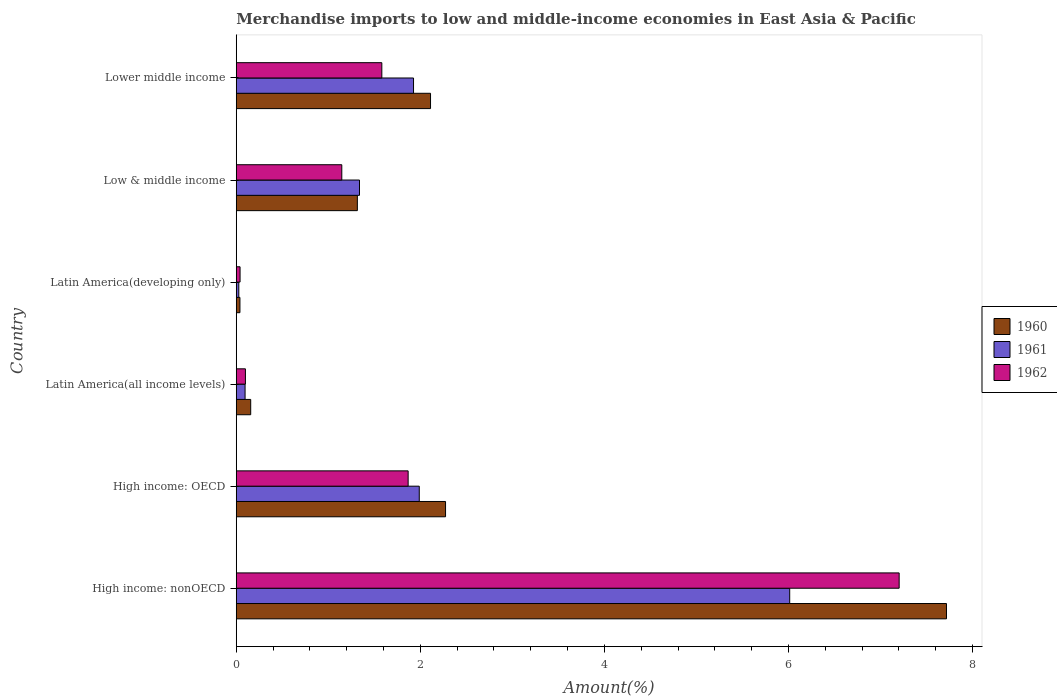How many different coloured bars are there?
Keep it short and to the point. 3. How many groups of bars are there?
Offer a terse response. 6. Are the number of bars per tick equal to the number of legend labels?
Ensure brevity in your answer.  Yes. Are the number of bars on each tick of the Y-axis equal?
Give a very brief answer. Yes. What is the label of the 3rd group of bars from the top?
Offer a terse response. Latin America(developing only). What is the percentage of amount earned from merchandise imports in 1961 in Latin America(developing only)?
Ensure brevity in your answer.  0.03. Across all countries, what is the maximum percentage of amount earned from merchandise imports in 1962?
Offer a very short reply. 7.2. Across all countries, what is the minimum percentage of amount earned from merchandise imports in 1962?
Your response must be concise. 0.04. In which country was the percentage of amount earned from merchandise imports in 1961 maximum?
Give a very brief answer. High income: nonOECD. In which country was the percentage of amount earned from merchandise imports in 1960 minimum?
Provide a short and direct response. Latin America(developing only). What is the total percentage of amount earned from merchandise imports in 1961 in the graph?
Offer a terse response. 11.39. What is the difference between the percentage of amount earned from merchandise imports in 1962 in High income: OECD and that in High income: nonOECD?
Your response must be concise. -5.33. What is the difference between the percentage of amount earned from merchandise imports in 1962 in High income: OECD and the percentage of amount earned from merchandise imports in 1961 in High income: nonOECD?
Your response must be concise. -4.15. What is the average percentage of amount earned from merchandise imports in 1960 per country?
Give a very brief answer. 2.27. What is the difference between the percentage of amount earned from merchandise imports in 1962 and percentage of amount earned from merchandise imports in 1960 in Latin America(all income levels)?
Provide a succinct answer. -0.06. What is the ratio of the percentage of amount earned from merchandise imports in 1962 in High income: OECD to that in Latin America(developing only)?
Keep it short and to the point. 45.19. Is the percentage of amount earned from merchandise imports in 1961 in High income: OECD less than that in Latin America(all income levels)?
Provide a succinct answer. No. What is the difference between the highest and the second highest percentage of amount earned from merchandise imports in 1961?
Ensure brevity in your answer.  4.02. What is the difference between the highest and the lowest percentage of amount earned from merchandise imports in 1960?
Give a very brief answer. 7.68. How many bars are there?
Offer a terse response. 18. Are all the bars in the graph horizontal?
Ensure brevity in your answer.  Yes. How many countries are there in the graph?
Your response must be concise. 6. What is the difference between two consecutive major ticks on the X-axis?
Make the answer very short. 2. Are the values on the major ticks of X-axis written in scientific E-notation?
Provide a succinct answer. No. Does the graph contain grids?
Keep it short and to the point. No. How many legend labels are there?
Give a very brief answer. 3. What is the title of the graph?
Offer a very short reply. Merchandise imports to low and middle-income economies in East Asia & Pacific. Does "1984" appear as one of the legend labels in the graph?
Make the answer very short. No. What is the label or title of the X-axis?
Your answer should be compact. Amount(%). What is the label or title of the Y-axis?
Your answer should be compact. Country. What is the Amount(%) in 1960 in High income: nonOECD?
Your response must be concise. 7.72. What is the Amount(%) of 1961 in High income: nonOECD?
Provide a short and direct response. 6.01. What is the Amount(%) in 1962 in High income: nonOECD?
Ensure brevity in your answer.  7.2. What is the Amount(%) in 1960 in High income: OECD?
Your response must be concise. 2.27. What is the Amount(%) of 1961 in High income: OECD?
Offer a very short reply. 1.99. What is the Amount(%) in 1962 in High income: OECD?
Keep it short and to the point. 1.87. What is the Amount(%) of 1960 in Latin America(all income levels)?
Give a very brief answer. 0.16. What is the Amount(%) of 1961 in Latin America(all income levels)?
Your answer should be very brief. 0.1. What is the Amount(%) of 1962 in Latin America(all income levels)?
Your answer should be compact. 0.1. What is the Amount(%) of 1960 in Latin America(developing only)?
Provide a succinct answer. 0.04. What is the Amount(%) of 1961 in Latin America(developing only)?
Keep it short and to the point. 0.03. What is the Amount(%) of 1962 in Latin America(developing only)?
Offer a very short reply. 0.04. What is the Amount(%) of 1960 in Low & middle income?
Give a very brief answer. 1.32. What is the Amount(%) in 1961 in Low & middle income?
Your answer should be compact. 1.34. What is the Amount(%) of 1962 in Low & middle income?
Your answer should be very brief. 1.15. What is the Amount(%) of 1960 in Lower middle income?
Keep it short and to the point. 2.11. What is the Amount(%) in 1961 in Lower middle income?
Keep it short and to the point. 1.93. What is the Amount(%) in 1962 in Lower middle income?
Offer a very short reply. 1.58. Across all countries, what is the maximum Amount(%) in 1960?
Make the answer very short. 7.72. Across all countries, what is the maximum Amount(%) of 1961?
Your answer should be very brief. 6.01. Across all countries, what is the maximum Amount(%) in 1962?
Your response must be concise. 7.2. Across all countries, what is the minimum Amount(%) of 1960?
Your answer should be compact. 0.04. Across all countries, what is the minimum Amount(%) in 1961?
Keep it short and to the point. 0.03. Across all countries, what is the minimum Amount(%) of 1962?
Provide a short and direct response. 0.04. What is the total Amount(%) of 1960 in the graph?
Make the answer very short. 13.61. What is the total Amount(%) in 1961 in the graph?
Your answer should be compact. 11.39. What is the total Amount(%) in 1962 in the graph?
Provide a short and direct response. 11.94. What is the difference between the Amount(%) in 1960 in High income: nonOECD and that in High income: OECD?
Your answer should be very brief. 5.44. What is the difference between the Amount(%) in 1961 in High income: nonOECD and that in High income: OECD?
Your answer should be very brief. 4.02. What is the difference between the Amount(%) of 1962 in High income: nonOECD and that in High income: OECD?
Offer a very short reply. 5.33. What is the difference between the Amount(%) of 1960 in High income: nonOECD and that in Latin America(all income levels)?
Your answer should be compact. 7.56. What is the difference between the Amount(%) in 1961 in High income: nonOECD and that in Latin America(all income levels)?
Ensure brevity in your answer.  5.92. What is the difference between the Amount(%) in 1962 in High income: nonOECD and that in Latin America(all income levels)?
Give a very brief answer. 7.1. What is the difference between the Amount(%) in 1960 in High income: nonOECD and that in Latin America(developing only)?
Provide a succinct answer. 7.68. What is the difference between the Amount(%) in 1961 in High income: nonOECD and that in Latin America(developing only)?
Make the answer very short. 5.99. What is the difference between the Amount(%) in 1962 in High income: nonOECD and that in Latin America(developing only)?
Give a very brief answer. 7.16. What is the difference between the Amount(%) in 1960 in High income: nonOECD and that in Low & middle income?
Provide a succinct answer. 6.4. What is the difference between the Amount(%) of 1961 in High income: nonOECD and that in Low & middle income?
Make the answer very short. 4.67. What is the difference between the Amount(%) of 1962 in High income: nonOECD and that in Low & middle income?
Your answer should be compact. 6.06. What is the difference between the Amount(%) of 1960 in High income: nonOECD and that in Lower middle income?
Make the answer very short. 5.61. What is the difference between the Amount(%) in 1961 in High income: nonOECD and that in Lower middle income?
Offer a very short reply. 4.09. What is the difference between the Amount(%) in 1962 in High income: nonOECD and that in Lower middle income?
Offer a terse response. 5.62. What is the difference between the Amount(%) in 1960 in High income: OECD and that in Latin America(all income levels)?
Your answer should be very brief. 2.12. What is the difference between the Amount(%) of 1961 in High income: OECD and that in Latin America(all income levels)?
Offer a very short reply. 1.89. What is the difference between the Amount(%) of 1962 in High income: OECD and that in Latin America(all income levels)?
Ensure brevity in your answer.  1.77. What is the difference between the Amount(%) of 1960 in High income: OECD and that in Latin America(developing only)?
Ensure brevity in your answer.  2.23. What is the difference between the Amount(%) in 1961 in High income: OECD and that in Latin America(developing only)?
Your answer should be compact. 1.96. What is the difference between the Amount(%) in 1962 in High income: OECD and that in Latin America(developing only)?
Make the answer very short. 1.83. What is the difference between the Amount(%) in 1960 in High income: OECD and that in Low & middle income?
Provide a short and direct response. 0.96. What is the difference between the Amount(%) in 1961 in High income: OECD and that in Low & middle income?
Give a very brief answer. 0.65. What is the difference between the Amount(%) in 1962 in High income: OECD and that in Low & middle income?
Offer a very short reply. 0.72. What is the difference between the Amount(%) in 1960 in High income: OECD and that in Lower middle income?
Make the answer very short. 0.16. What is the difference between the Amount(%) in 1961 in High income: OECD and that in Lower middle income?
Your response must be concise. 0.06. What is the difference between the Amount(%) in 1962 in High income: OECD and that in Lower middle income?
Your response must be concise. 0.29. What is the difference between the Amount(%) of 1960 in Latin America(all income levels) and that in Latin America(developing only)?
Make the answer very short. 0.12. What is the difference between the Amount(%) of 1961 in Latin America(all income levels) and that in Latin America(developing only)?
Provide a short and direct response. 0.07. What is the difference between the Amount(%) of 1962 in Latin America(all income levels) and that in Latin America(developing only)?
Keep it short and to the point. 0.06. What is the difference between the Amount(%) in 1960 in Latin America(all income levels) and that in Low & middle income?
Make the answer very short. -1.16. What is the difference between the Amount(%) of 1961 in Latin America(all income levels) and that in Low & middle income?
Provide a succinct answer. -1.24. What is the difference between the Amount(%) in 1962 in Latin America(all income levels) and that in Low & middle income?
Provide a succinct answer. -1.05. What is the difference between the Amount(%) in 1960 in Latin America(all income levels) and that in Lower middle income?
Keep it short and to the point. -1.95. What is the difference between the Amount(%) in 1961 in Latin America(all income levels) and that in Lower middle income?
Provide a succinct answer. -1.83. What is the difference between the Amount(%) of 1962 in Latin America(all income levels) and that in Lower middle income?
Make the answer very short. -1.48. What is the difference between the Amount(%) in 1960 in Latin America(developing only) and that in Low & middle income?
Make the answer very short. -1.28. What is the difference between the Amount(%) of 1961 in Latin America(developing only) and that in Low & middle income?
Give a very brief answer. -1.31. What is the difference between the Amount(%) of 1962 in Latin America(developing only) and that in Low & middle income?
Make the answer very short. -1.11. What is the difference between the Amount(%) of 1960 in Latin America(developing only) and that in Lower middle income?
Offer a terse response. -2.07. What is the difference between the Amount(%) in 1961 in Latin America(developing only) and that in Lower middle income?
Your answer should be very brief. -1.9. What is the difference between the Amount(%) in 1962 in Latin America(developing only) and that in Lower middle income?
Keep it short and to the point. -1.54. What is the difference between the Amount(%) in 1960 in Low & middle income and that in Lower middle income?
Your response must be concise. -0.8. What is the difference between the Amount(%) in 1961 in Low & middle income and that in Lower middle income?
Your answer should be very brief. -0.59. What is the difference between the Amount(%) of 1962 in Low & middle income and that in Lower middle income?
Give a very brief answer. -0.43. What is the difference between the Amount(%) of 1960 in High income: nonOECD and the Amount(%) of 1961 in High income: OECD?
Give a very brief answer. 5.73. What is the difference between the Amount(%) in 1960 in High income: nonOECD and the Amount(%) in 1962 in High income: OECD?
Ensure brevity in your answer.  5.85. What is the difference between the Amount(%) of 1961 in High income: nonOECD and the Amount(%) of 1962 in High income: OECD?
Provide a succinct answer. 4.15. What is the difference between the Amount(%) in 1960 in High income: nonOECD and the Amount(%) in 1961 in Latin America(all income levels)?
Offer a very short reply. 7.62. What is the difference between the Amount(%) of 1960 in High income: nonOECD and the Amount(%) of 1962 in Latin America(all income levels)?
Give a very brief answer. 7.62. What is the difference between the Amount(%) of 1961 in High income: nonOECD and the Amount(%) of 1962 in Latin America(all income levels)?
Your answer should be very brief. 5.91. What is the difference between the Amount(%) of 1960 in High income: nonOECD and the Amount(%) of 1961 in Latin America(developing only)?
Ensure brevity in your answer.  7.69. What is the difference between the Amount(%) in 1960 in High income: nonOECD and the Amount(%) in 1962 in Latin America(developing only)?
Your answer should be very brief. 7.67. What is the difference between the Amount(%) of 1961 in High income: nonOECD and the Amount(%) of 1962 in Latin America(developing only)?
Give a very brief answer. 5.97. What is the difference between the Amount(%) of 1960 in High income: nonOECD and the Amount(%) of 1961 in Low & middle income?
Your answer should be very brief. 6.38. What is the difference between the Amount(%) of 1960 in High income: nonOECD and the Amount(%) of 1962 in Low & middle income?
Your answer should be very brief. 6.57. What is the difference between the Amount(%) of 1961 in High income: nonOECD and the Amount(%) of 1962 in Low & middle income?
Provide a succinct answer. 4.87. What is the difference between the Amount(%) of 1960 in High income: nonOECD and the Amount(%) of 1961 in Lower middle income?
Offer a terse response. 5.79. What is the difference between the Amount(%) of 1960 in High income: nonOECD and the Amount(%) of 1962 in Lower middle income?
Provide a succinct answer. 6.13. What is the difference between the Amount(%) of 1961 in High income: nonOECD and the Amount(%) of 1962 in Lower middle income?
Keep it short and to the point. 4.43. What is the difference between the Amount(%) in 1960 in High income: OECD and the Amount(%) in 1961 in Latin America(all income levels)?
Your response must be concise. 2.18. What is the difference between the Amount(%) in 1960 in High income: OECD and the Amount(%) in 1962 in Latin America(all income levels)?
Keep it short and to the point. 2.17. What is the difference between the Amount(%) in 1961 in High income: OECD and the Amount(%) in 1962 in Latin America(all income levels)?
Offer a very short reply. 1.89. What is the difference between the Amount(%) in 1960 in High income: OECD and the Amount(%) in 1961 in Latin America(developing only)?
Keep it short and to the point. 2.25. What is the difference between the Amount(%) in 1960 in High income: OECD and the Amount(%) in 1962 in Latin America(developing only)?
Your answer should be compact. 2.23. What is the difference between the Amount(%) of 1961 in High income: OECD and the Amount(%) of 1962 in Latin America(developing only)?
Make the answer very short. 1.95. What is the difference between the Amount(%) of 1960 in High income: OECD and the Amount(%) of 1961 in Low & middle income?
Your response must be concise. 0.93. What is the difference between the Amount(%) in 1960 in High income: OECD and the Amount(%) in 1962 in Low & middle income?
Your answer should be compact. 1.13. What is the difference between the Amount(%) of 1961 in High income: OECD and the Amount(%) of 1962 in Low & middle income?
Provide a short and direct response. 0.84. What is the difference between the Amount(%) in 1960 in High income: OECD and the Amount(%) in 1961 in Lower middle income?
Your answer should be compact. 0.35. What is the difference between the Amount(%) in 1960 in High income: OECD and the Amount(%) in 1962 in Lower middle income?
Keep it short and to the point. 0.69. What is the difference between the Amount(%) of 1961 in High income: OECD and the Amount(%) of 1962 in Lower middle income?
Give a very brief answer. 0.41. What is the difference between the Amount(%) of 1960 in Latin America(all income levels) and the Amount(%) of 1961 in Latin America(developing only)?
Provide a succinct answer. 0.13. What is the difference between the Amount(%) in 1960 in Latin America(all income levels) and the Amount(%) in 1962 in Latin America(developing only)?
Ensure brevity in your answer.  0.12. What is the difference between the Amount(%) in 1961 in Latin America(all income levels) and the Amount(%) in 1962 in Latin America(developing only)?
Your response must be concise. 0.05. What is the difference between the Amount(%) of 1960 in Latin America(all income levels) and the Amount(%) of 1961 in Low & middle income?
Ensure brevity in your answer.  -1.18. What is the difference between the Amount(%) of 1960 in Latin America(all income levels) and the Amount(%) of 1962 in Low & middle income?
Keep it short and to the point. -0.99. What is the difference between the Amount(%) of 1961 in Latin America(all income levels) and the Amount(%) of 1962 in Low & middle income?
Make the answer very short. -1.05. What is the difference between the Amount(%) of 1960 in Latin America(all income levels) and the Amount(%) of 1961 in Lower middle income?
Provide a succinct answer. -1.77. What is the difference between the Amount(%) of 1960 in Latin America(all income levels) and the Amount(%) of 1962 in Lower middle income?
Provide a succinct answer. -1.42. What is the difference between the Amount(%) in 1961 in Latin America(all income levels) and the Amount(%) in 1962 in Lower middle income?
Give a very brief answer. -1.49. What is the difference between the Amount(%) in 1960 in Latin America(developing only) and the Amount(%) in 1961 in Low & middle income?
Your answer should be very brief. -1.3. What is the difference between the Amount(%) in 1960 in Latin America(developing only) and the Amount(%) in 1962 in Low & middle income?
Keep it short and to the point. -1.11. What is the difference between the Amount(%) of 1961 in Latin America(developing only) and the Amount(%) of 1962 in Low & middle income?
Offer a terse response. -1.12. What is the difference between the Amount(%) in 1960 in Latin America(developing only) and the Amount(%) in 1961 in Lower middle income?
Make the answer very short. -1.89. What is the difference between the Amount(%) in 1960 in Latin America(developing only) and the Amount(%) in 1962 in Lower middle income?
Your answer should be very brief. -1.54. What is the difference between the Amount(%) in 1961 in Latin America(developing only) and the Amount(%) in 1962 in Lower middle income?
Provide a short and direct response. -1.55. What is the difference between the Amount(%) in 1960 in Low & middle income and the Amount(%) in 1961 in Lower middle income?
Offer a terse response. -0.61. What is the difference between the Amount(%) in 1960 in Low & middle income and the Amount(%) in 1962 in Lower middle income?
Your answer should be very brief. -0.27. What is the difference between the Amount(%) in 1961 in Low & middle income and the Amount(%) in 1962 in Lower middle income?
Your answer should be very brief. -0.24. What is the average Amount(%) in 1960 per country?
Keep it short and to the point. 2.27. What is the average Amount(%) in 1961 per country?
Offer a terse response. 1.9. What is the average Amount(%) of 1962 per country?
Make the answer very short. 1.99. What is the difference between the Amount(%) in 1960 and Amount(%) in 1961 in High income: nonOECD?
Provide a short and direct response. 1.7. What is the difference between the Amount(%) in 1960 and Amount(%) in 1962 in High income: nonOECD?
Ensure brevity in your answer.  0.51. What is the difference between the Amount(%) in 1961 and Amount(%) in 1962 in High income: nonOECD?
Offer a very short reply. -1.19. What is the difference between the Amount(%) of 1960 and Amount(%) of 1961 in High income: OECD?
Give a very brief answer. 0.29. What is the difference between the Amount(%) of 1960 and Amount(%) of 1962 in High income: OECD?
Give a very brief answer. 0.41. What is the difference between the Amount(%) in 1961 and Amount(%) in 1962 in High income: OECD?
Give a very brief answer. 0.12. What is the difference between the Amount(%) of 1960 and Amount(%) of 1961 in Latin America(all income levels)?
Your answer should be compact. 0.06. What is the difference between the Amount(%) of 1960 and Amount(%) of 1962 in Latin America(all income levels)?
Ensure brevity in your answer.  0.06. What is the difference between the Amount(%) in 1961 and Amount(%) in 1962 in Latin America(all income levels)?
Make the answer very short. -0. What is the difference between the Amount(%) of 1960 and Amount(%) of 1961 in Latin America(developing only)?
Your answer should be very brief. 0.01. What is the difference between the Amount(%) in 1960 and Amount(%) in 1962 in Latin America(developing only)?
Ensure brevity in your answer.  -0. What is the difference between the Amount(%) in 1961 and Amount(%) in 1962 in Latin America(developing only)?
Your answer should be very brief. -0.01. What is the difference between the Amount(%) in 1960 and Amount(%) in 1961 in Low & middle income?
Provide a succinct answer. -0.02. What is the difference between the Amount(%) of 1960 and Amount(%) of 1962 in Low & middle income?
Provide a succinct answer. 0.17. What is the difference between the Amount(%) of 1961 and Amount(%) of 1962 in Low & middle income?
Your answer should be compact. 0.19. What is the difference between the Amount(%) in 1960 and Amount(%) in 1961 in Lower middle income?
Provide a short and direct response. 0.18. What is the difference between the Amount(%) of 1960 and Amount(%) of 1962 in Lower middle income?
Your answer should be very brief. 0.53. What is the difference between the Amount(%) in 1961 and Amount(%) in 1962 in Lower middle income?
Your answer should be compact. 0.34. What is the ratio of the Amount(%) of 1960 in High income: nonOECD to that in High income: OECD?
Give a very brief answer. 3.39. What is the ratio of the Amount(%) in 1961 in High income: nonOECD to that in High income: OECD?
Offer a very short reply. 3.02. What is the ratio of the Amount(%) in 1962 in High income: nonOECD to that in High income: OECD?
Give a very brief answer. 3.86. What is the ratio of the Amount(%) of 1960 in High income: nonOECD to that in Latin America(all income levels)?
Offer a terse response. 49.18. What is the ratio of the Amount(%) in 1961 in High income: nonOECD to that in Latin America(all income levels)?
Give a very brief answer. 62.77. What is the ratio of the Amount(%) in 1962 in High income: nonOECD to that in Latin America(all income levels)?
Provide a succinct answer. 72.3. What is the ratio of the Amount(%) of 1960 in High income: nonOECD to that in Latin America(developing only)?
Your response must be concise. 192.42. What is the ratio of the Amount(%) of 1961 in High income: nonOECD to that in Latin America(developing only)?
Keep it short and to the point. 216.41. What is the ratio of the Amount(%) in 1962 in High income: nonOECD to that in Latin America(developing only)?
Make the answer very short. 174.29. What is the ratio of the Amount(%) of 1960 in High income: nonOECD to that in Low & middle income?
Ensure brevity in your answer.  5.86. What is the ratio of the Amount(%) in 1961 in High income: nonOECD to that in Low & middle income?
Keep it short and to the point. 4.49. What is the ratio of the Amount(%) in 1962 in High income: nonOECD to that in Low & middle income?
Offer a very short reply. 6.28. What is the ratio of the Amount(%) of 1960 in High income: nonOECD to that in Lower middle income?
Your response must be concise. 3.66. What is the ratio of the Amount(%) of 1961 in High income: nonOECD to that in Lower middle income?
Keep it short and to the point. 3.12. What is the ratio of the Amount(%) of 1962 in High income: nonOECD to that in Lower middle income?
Offer a very short reply. 4.55. What is the ratio of the Amount(%) in 1960 in High income: OECD to that in Latin America(all income levels)?
Give a very brief answer. 14.49. What is the ratio of the Amount(%) in 1961 in High income: OECD to that in Latin America(all income levels)?
Give a very brief answer. 20.76. What is the ratio of the Amount(%) in 1962 in High income: OECD to that in Latin America(all income levels)?
Your response must be concise. 18.75. What is the ratio of the Amount(%) in 1960 in High income: OECD to that in Latin America(developing only)?
Offer a terse response. 56.7. What is the ratio of the Amount(%) in 1961 in High income: OECD to that in Latin America(developing only)?
Your response must be concise. 71.56. What is the ratio of the Amount(%) in 1962 in High income: OECD to that in Latin America(developing only)?
Provide a short and direct response. 45.19. What is the ratio of the Amount(%) of 1960 in High income: OECD to that in Low & middle income?
Your response must be concise. 1.73. What is the ratio of the Amount(%) in 1961 in High income: OECD to that in Low & middle income?
Offer a terse response. 1.48. What is the ratio of the Amount(%) in 1962 in High income: OECD to that in Low & middle income?
Ensure brevity in your answer.  1.63. What is the ratio of the Amount(%) in 1960 in High income: OECD to that in Lower middle income?
Ensure brevity in your answer.  1.08. What is the ratio of the Amount(%) in 1961 in High income: OECD to that in Lower middle income?
Offer a terse response. 1.03. What is the ratio of the Amount(%) in 1962 in High income: OECD to that in Lower middle income?
Keep it short and to the point. 1.18. What is the ratio of the Amount(%) in 1960 in Latin America(all income levels) to that in Latin America(developing only)?
Your answer should be compact. 3.91. What is the ratio of the Amount(%) in 1961 in Latin America(all income levels) to that in Latin America(developing only)?
Your response must be concise. 3.45. What is the ratio of the Amount(%) of 1962 in Latin America(all income levels) to that in Latin America(developing only)?
Make the answer very short. 2.41. What is the ratio of the Amount(%) of 1960 in Latin America(all income levels) to that in Low & middle income?
Offer a very short reply. 0.12. What is the ratio of the Amount(%) of 1961 in Latin America(all income levels) to that in Low & middle income?
Provide a short and direct response. 0.07. What is the ratio of the Amount(%) in 1962 in Latin America(all income levels) to that in Low & middle income?
Make the answer very short. 0.09. What is the ratio of the Amount(%) of 1960 in Latin America(all income levels) to that in Lower middle income?
Provide a short and direct response. 0.07. What is the ratio of the Amount(%) of 1961 in Latin America(all income levels) to that in Lower middle income?
Offer a very short reply. 0.05. What is the ratio of the Amount(%) of 1962 in Latin America(all income levels) to that in Lower middle income?
Offer a terse response. 0.06. What is the ratio of the Amount(%) of 1960 in Latin America(developing only) to that in Low & middle income?
Your answer should be very brief. 0.03. What is the ratio of the Amount(%) in 1961 in Latin America(developing only) to that in Low & middle income?
Your response must be concise. 0.02. What is the ratio of the Amount(%) of 1962 in Latin America(developing only) to that in Low & middle income?
Offer a terse response. 0.04. What is the ratio of the Amount(%) of 1960 in Latin America(developing only) to that in Lower middle income?
Give a very brief answer. 0.02. What is the ratio of the Amount(%) of 1961 in Latin America(developing only) to that in Lower middle income?
Provide a succinct answer. 0.01. What is the ratio of the Amount(%) of 1962 in Latin America(developing only) to that in Lower middle income?
Keep it short and to the point. 0.03. What is the ratio of the Amount(%) in 1960 in Low & middle income to that in Lower middle income?
Offer a very short reply. 0.62. What is the ratio of the Amount(%) in 1961 in Low & middle income to that in Lower middle income?
Provide a succinct answer. 0.7. What is the ratio of the Amount(%) of 1962 in Low & middle income to that in Lower middle income?
Provide a short and direct response. 0.73. What is the difference between the highest and the second highest Amount(%) of 1960?
Offer a terse response. 5.44. What is the difference between the highest and the second highest Amount(%) in 1961?
Provide a short and direct response. 4.02. What is the difference between the highest and the second highest Amount(%) of 1962?
Provide a short and direct response. 5.33. What is the difference between the highest and the lowest Amount(%) of 1960?
Provide a succinct answer. 7.68. What is the difference between the highest and the lowest Amount(%) in 1961?
Offer a very short reply. 5.99. What is the difference between the highest and the lowest Amount(%) in 1962?
Your response must be concise. 7.16. 